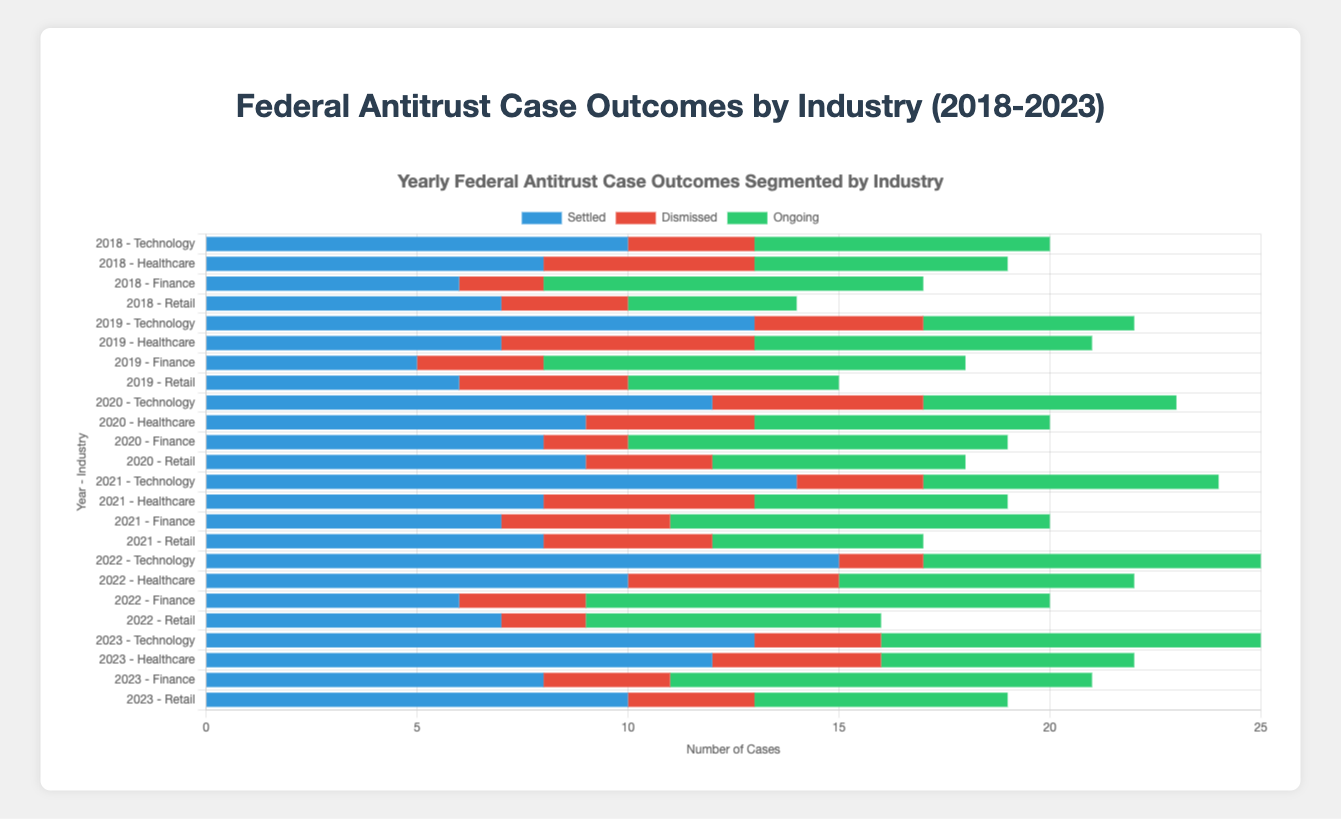Which industry had the highest number of settled cases in 2022? To determine the highest number of settled cases, look at the bars corresponding to 2022 and compare the segments labeled "Settled" for each industry. The "Technology" industry had the highest number of settled cases at 15.
Answer: Technology Which year had the most ongoing cases in the Healthcare industry? Compare the heights of the "Ongoing" segments for the Healthcare industry across all years. The year with the tallest "Ongoing" segment for Healthcare is 2019, with 8 ongoing cases.
Answer: 2019 In 2023, which industry had the fewest dismissed cases? Look at the bars corresponding to 2023 and compare the segments labeled "Dismissed" for each industry. The "Technology," "Retail," and "Finance" industries are tied with the fewest dismissed cases, each having 3 cases.
Answer: Technology, Retail, Finance What is the total number of dismissed cases in the Finance industry from 2018 to 2023? Sum up the dismissed cases for the Finance industry across all years: 2 (2018) + 3 (2019) + 2 (2020) + 4 (2021) + 3 (2022) + 3 (2023) = 17.
Answer: 17 Which industry had the most settled cases over the entire period (2018-2023)? Sum the "Settled" segments for each industry across all years and compare the totals. The "Technology" industry has the highest total of settled cases: 10 + 13 + 12 + 14 + 15 + 13 = 77.
Answer: Technology How did the number of ongoing cases in the Retail industry change from 2021 to 2023? Check the "Ongoing" segments for the Retail industry in 2021 and 2023: 5 (2021) to 6 (2023). The number of ongoing cases increased by 1.
Answer: Increased by 1 What was the average number of settled cases across all industries in 2019? Sum the settled cases for all industries in 2019 and divide by the number of industries. (13 + 7 + 5 + 6) / 4 = 31 / 4 = 7.75.
Answer: 7.75 